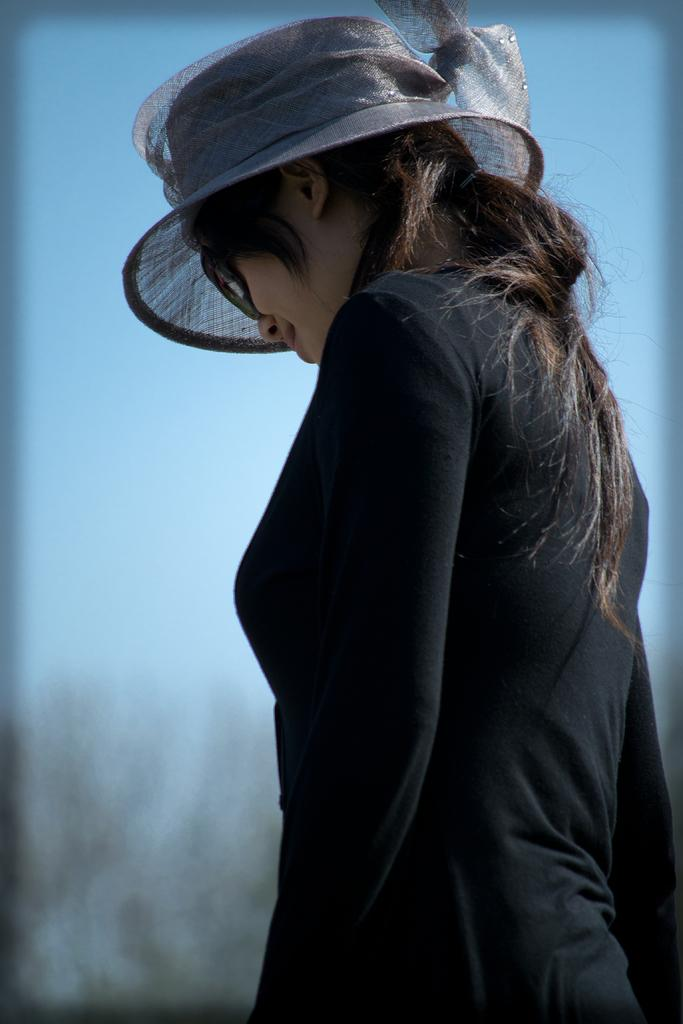Who is in the image? There is a woman in the image. What is the woman wearing? The woman is wearing a black dress and a black hat. What is the woman doing in the image? The woman is standing. What can be seen in the background of the image? There is sky and trees visible in the background of the image. What type of hole can be seen in the woman's dress in the image? There is no hole visible in the woman's dress in the image. What property does the woman own in the image? The image does not provide information about the woman owning any property. 